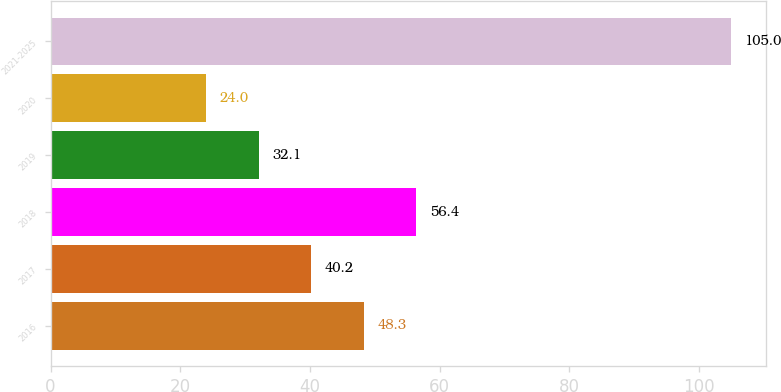Convert chart. <chart><loc_0><loc_0><loc_500><loc_500><bar_chart><fcel>2016<fcel>2017<fcel>2018<fcel>2019<fcel>2020<fcel>2021-2025<nl><fcel>48.3<fcel>40.2<fcel>56.4<fcel>32.1<fcel>24<fcel>105<nl></chart> 